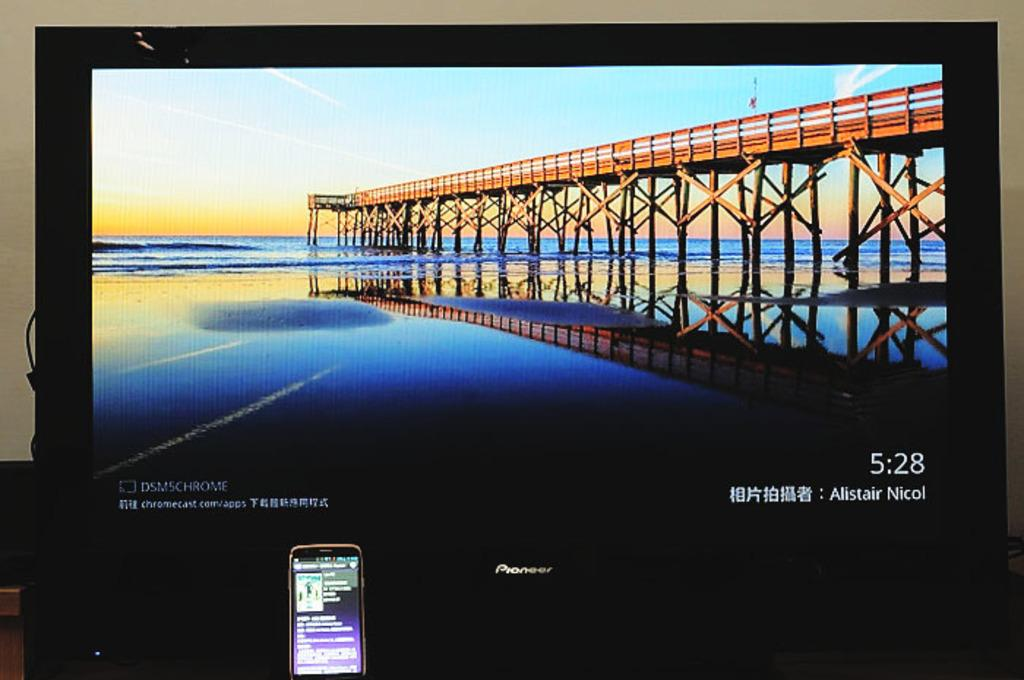<image>
Render a clear and concise summary of the photo. A computer monitor shows a picture of a pier and has the time listed as 5:28. 